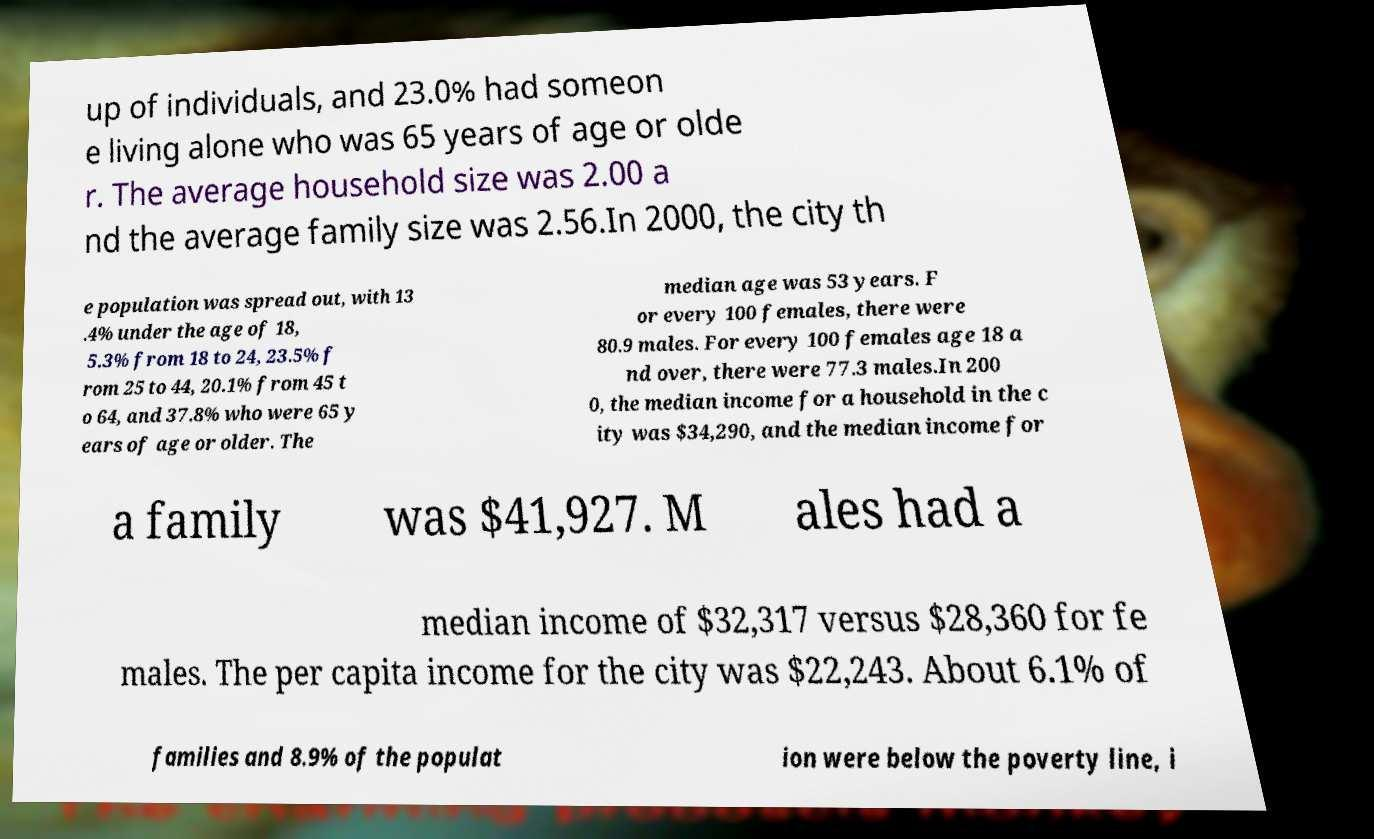Please read and relay the text visible in this image. What does it say? up of individuals, and 23.0% had someon e living alone who was 65 years of age or olde r. The average household size was 2.00 a nd the average family size was 2.56.In 2000, the city th e population was spread out, with 13 .4% under the age of 18, 5.3% from 18 to 24, 23.5% f rom 25 to 44, 20.1% from 45 t o 64, and 37.8% who were 65 y ears of age or older. The median age was 53 years. F or every 100 females, there were 80.9 males. For every 100 females age 18 a nd over, there were 77.3 males.In 200 0, the median income for a household in the c ity was $34,290, and the median income for a family was $41,927. M ales had a median income of $32,317 versus $28,360 for fe males. The per capita income for the city was $22,243. About 6.1% of families and 8.9% of the populat ion were below the poverty line, i 